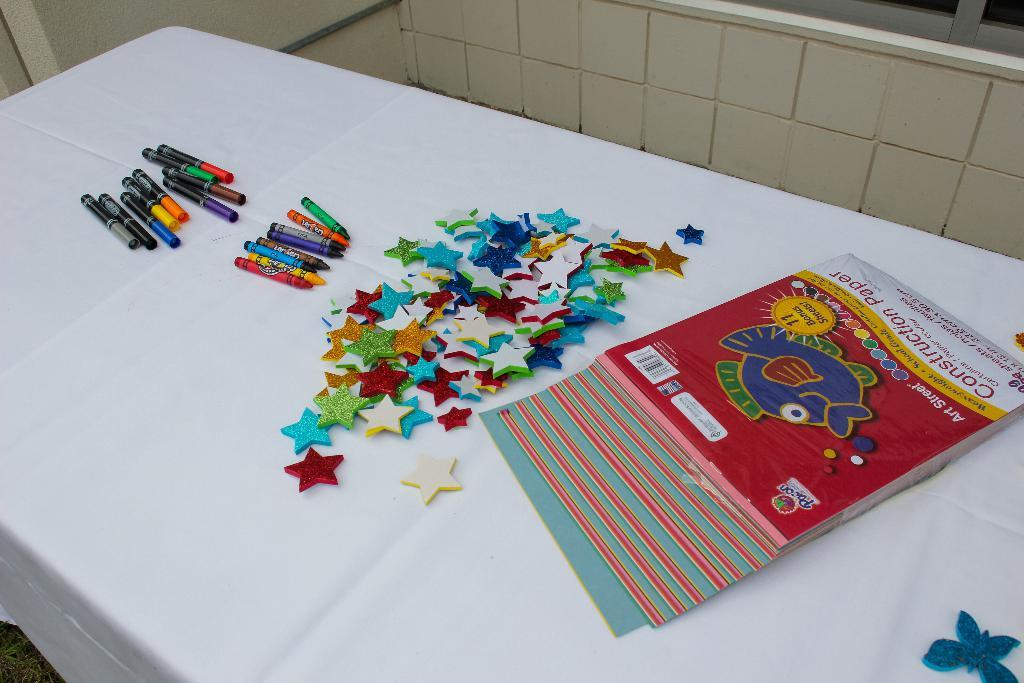What items can be seen in the image related to learning or creativity? There are books and crayons in the image. What is the color of the cloth on which the objects are placed? The cloth is white. Where is the white cloth located in the image? The white cloth is placed on a table. What can be seen in the background of the image? There is a wall visible in the background of the image. What type of texture can be seen on the dirt in the image? There is no dirt present in the image; it features books, crayons, and objects placed on a white cloth on a table with a wall visible in the background. 